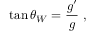<formula> <loc_0><loc_0><loc_500><loc_500>\tan \theta _ { W } = \frac { g ^ { \prime } } { g } \ ,</formula> 